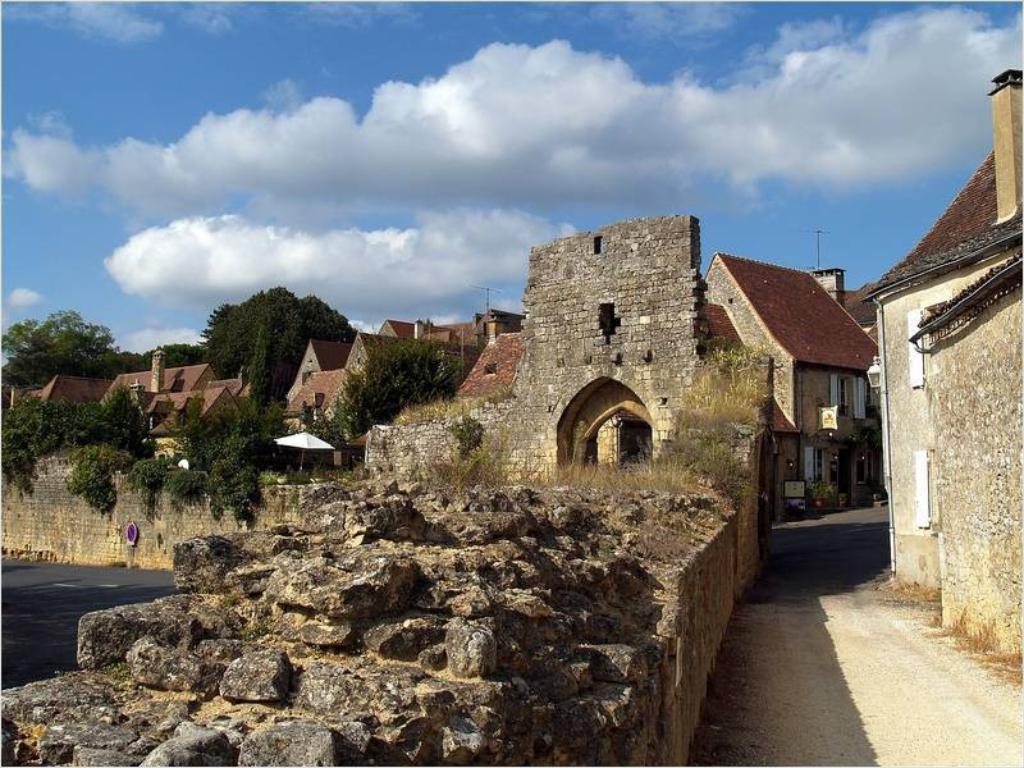What type of structures can be seen in the image? There are buildings in the image. What natural elements are present in the image? There are trees in the image. What man-made object can be seen in the image? There is a wall in the image. What is the purpose of the board in the image? The purpose of the board in the image is not specified, but it could be used for displaying information or as a surface for writing or drawing. What object is used for protection from rain in the image? There is an umbrella in the image. What part of the environment is visible in the image? The sky is visible in the image. What weather condition can be inferred from the image? Clouds are present in the sky, suggesting that it might be a partly cloudy day. Where is the toad sitting in the image? There is no toad present in the image. What type of skin is visible on the people in the image? There are no people present in the image, so it is not possible to determine the type of skin visible. 